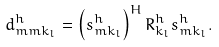<formula> <loc_0><loc_0><loc_500><loc_500>d ^ { h } _ { m m k _ { l } } = \left ( s ^ { h } _ { m k _ { l } } \right ) ^ { H } R _ { k _ { l } } ^ { h } s ^ { h } _ { m k _ { l } } .</formula> 